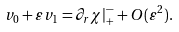<formula> <loc_0><loc_0><loc_500><loc_500>v _ { 0 } + \varepsilon v _ { 1 } = \partial _ { r } \chi | ^ { - } _ { + } + O ( \varepsilon ^ { 2 } ) .</formula> 